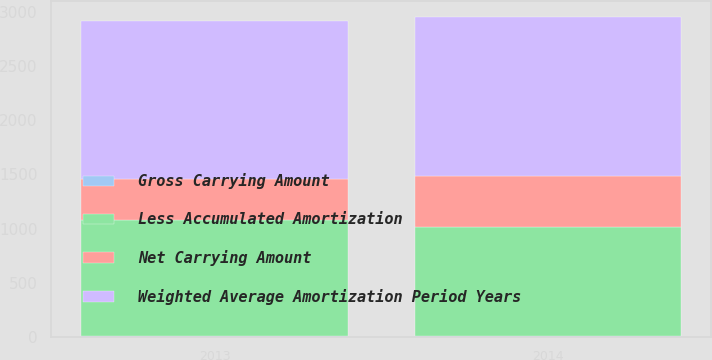<chart> <loc_0><loc_0><loc_500><loc_500><stacked_bar_chart><ecel><fcel>2014<fcel>2013<nl><fcel>Gross Carrying Amount<fcel>13<fcel>12<nl><fcel>Weighted Average Amortization Period Years<fcel>1468<fcel>1450<nl><fcel>Net Carrying Amount<fcel>466<fcel>380<nl><fcel>Less Accumulated Amortization<fcel>1002<fcel>1070<nl></chart> 